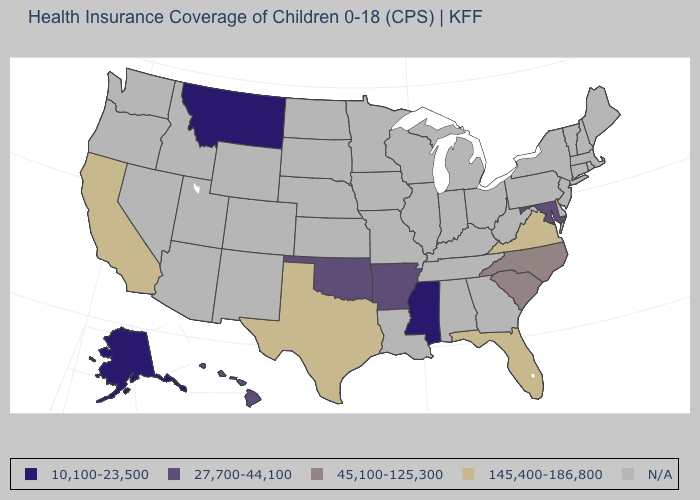Does the map have missing data?
Concise answer only. Yes. How many symbols are there in the legend?
Quick response, please. 5. What is the value of Massachusetts?
Short answer required. N/A. Name the states that have a value in the range 145,400-186,800?
Keep it brief. California, Florida, Texas, Virginia. How many symbols are there in the legend?
Answer briefly. 5. What is the highest value in the South ?
Short answer required. 145,400-186,800. What is the value of Louisiana?
Concise answer only. N/A. How many symbols are there in the legend?
Keep it brief. 5. What is the lowest value in states that border Pennsylvania?
Keep it brief. 27,700-44,100. What is the highest value in the USA?
Quick response, please. 145,400-186,800. What is the lowest value in states that border Wyoming?
Give a very brief answer. 10,100-23,500. Does the map have missing data?
Keep it brief. Yes. What is the value of California?
Quick response, please. 145,400-186,800. 